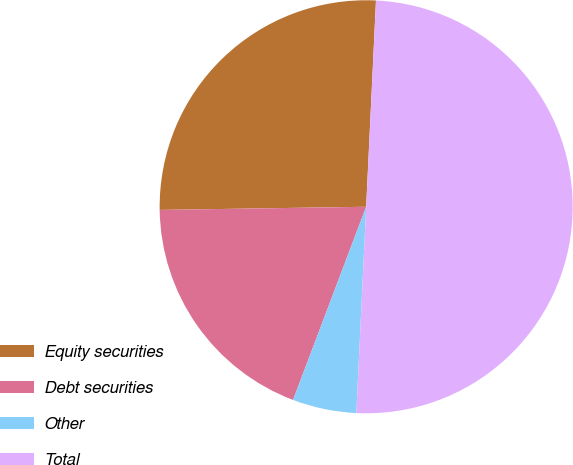Convert chart to OTSL. <chart><loc_0><loc_0><loc_500><loc_500><pie_chart><fcel>Equity securities<fcel>Debt securities<fcel>Other<fcel>Total<nl><fcel>26.0%<fcel>19.0%<fcel>5.0%<fcel>50.0%<nl></chart> 